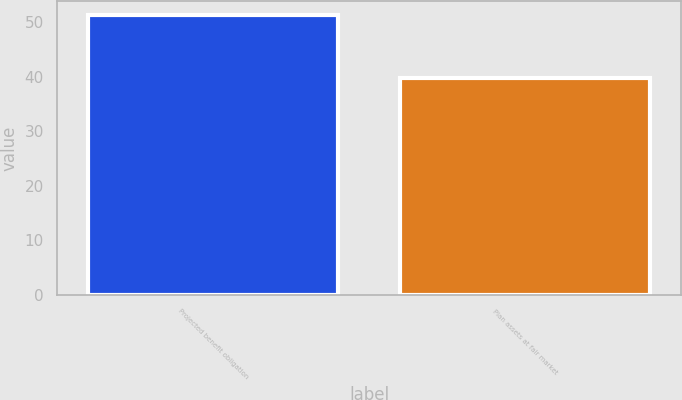<chart> <loc_0><loc_0><loc_500><loc_500><bar_chart><fcel>Projected benefit obligation<fcel>Plan assets at fair market<nl><fcel>51.3<fcel>39.8<nl></chart> 